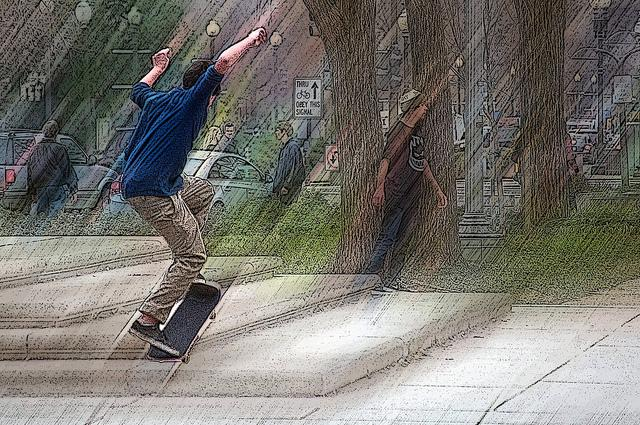World Skate is highest governing body of which game? skateboarding 